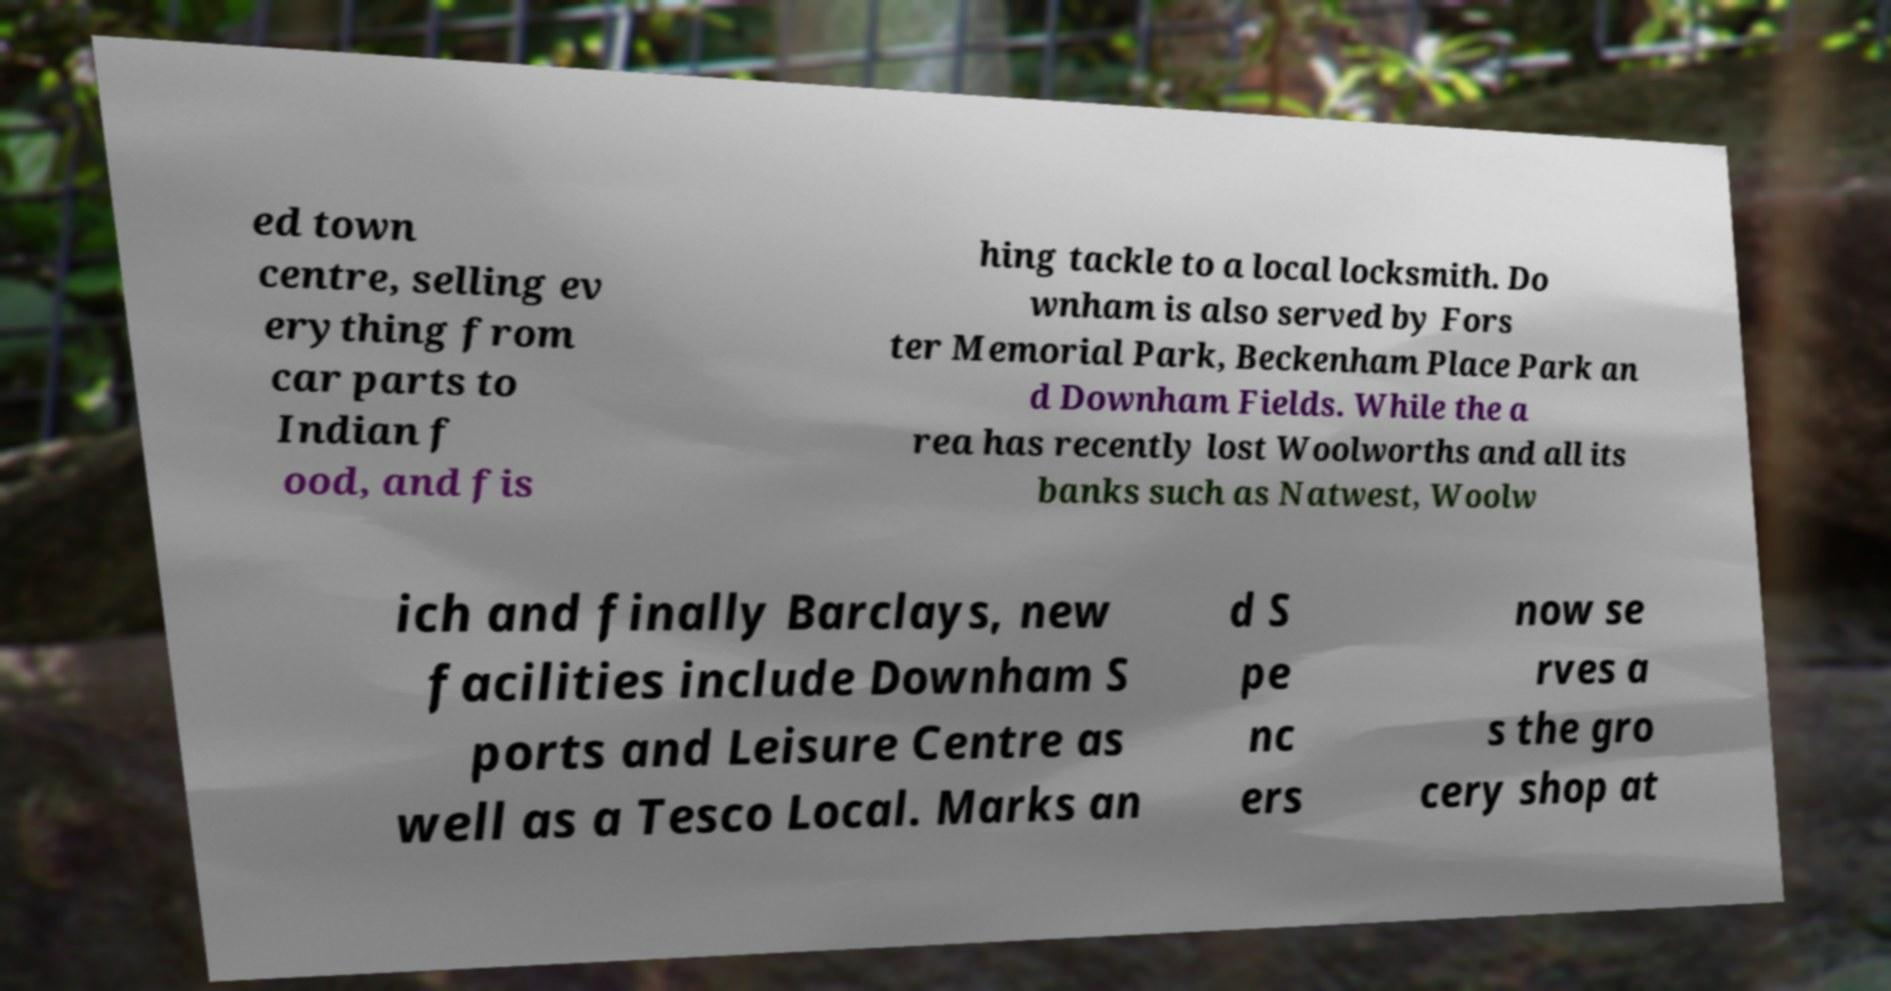Please identify and transcribe the text found in this image. ed town centre, selling ev erything from car parts to Indian f ood, and fis hing tackle to a local locksmith. Do wnham is also served by Fors ter Memorial Park, Beckenham Place Park an d Downham Fields. While the a rea has recently lost Woolworths and all its banks such as Natwest, Woolw ich and finally Barclays, new facilities include Downham S ports and Leisure Centre as well as a Tesco Local. Marks an d S pe nc ers now se rves a s the gro cery shop at 